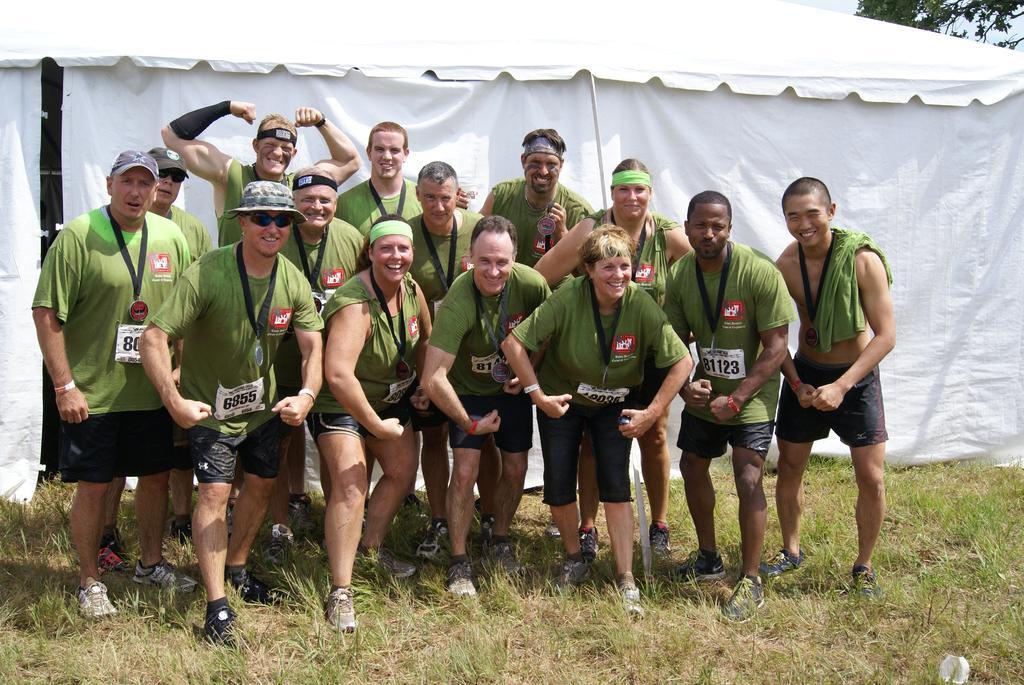Can you describe this image briefly? In the picture I can see a group of people are standing on the ground. These people are wearing green color t-shirts and black color shorts. In the background I can see a white color tent and the grass. 